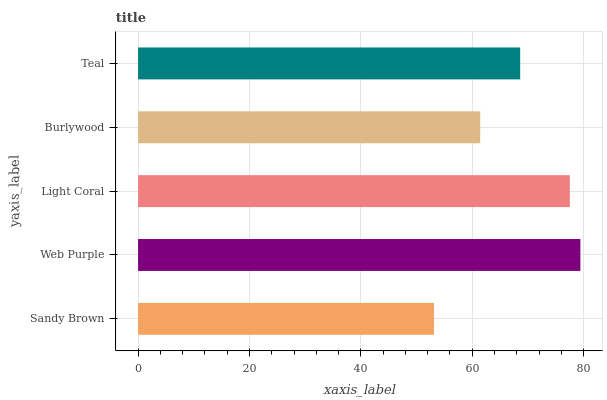Is Sandy Brown the minimum?
Answer yes or no. Yes. Is Web Purple the maximum?
Answer yes or no. Yes. Is Light Coral the minimum?
Answer yes or no. No. Is Light Coral the maximum?
Answer yes or no. No. Is Web Purple greater than Light Coral?
Answer yes or no. Yes. Is Light Coral less than Web Purple?
Answer yes or no. Yes. Is Light Coral greater than Web Purple?
Answer yes or no. No. Is Web Purple less than Light Coral?
Answer yes or no. No. Is Teal the high median?
Answer yes or no. Yes. Is Teal the low median?
Answer yes or no. Yes. Is Web Purple the high median?
Answer yes or no. No. Is Light Coral the low median?
Answer yes or no. No. 